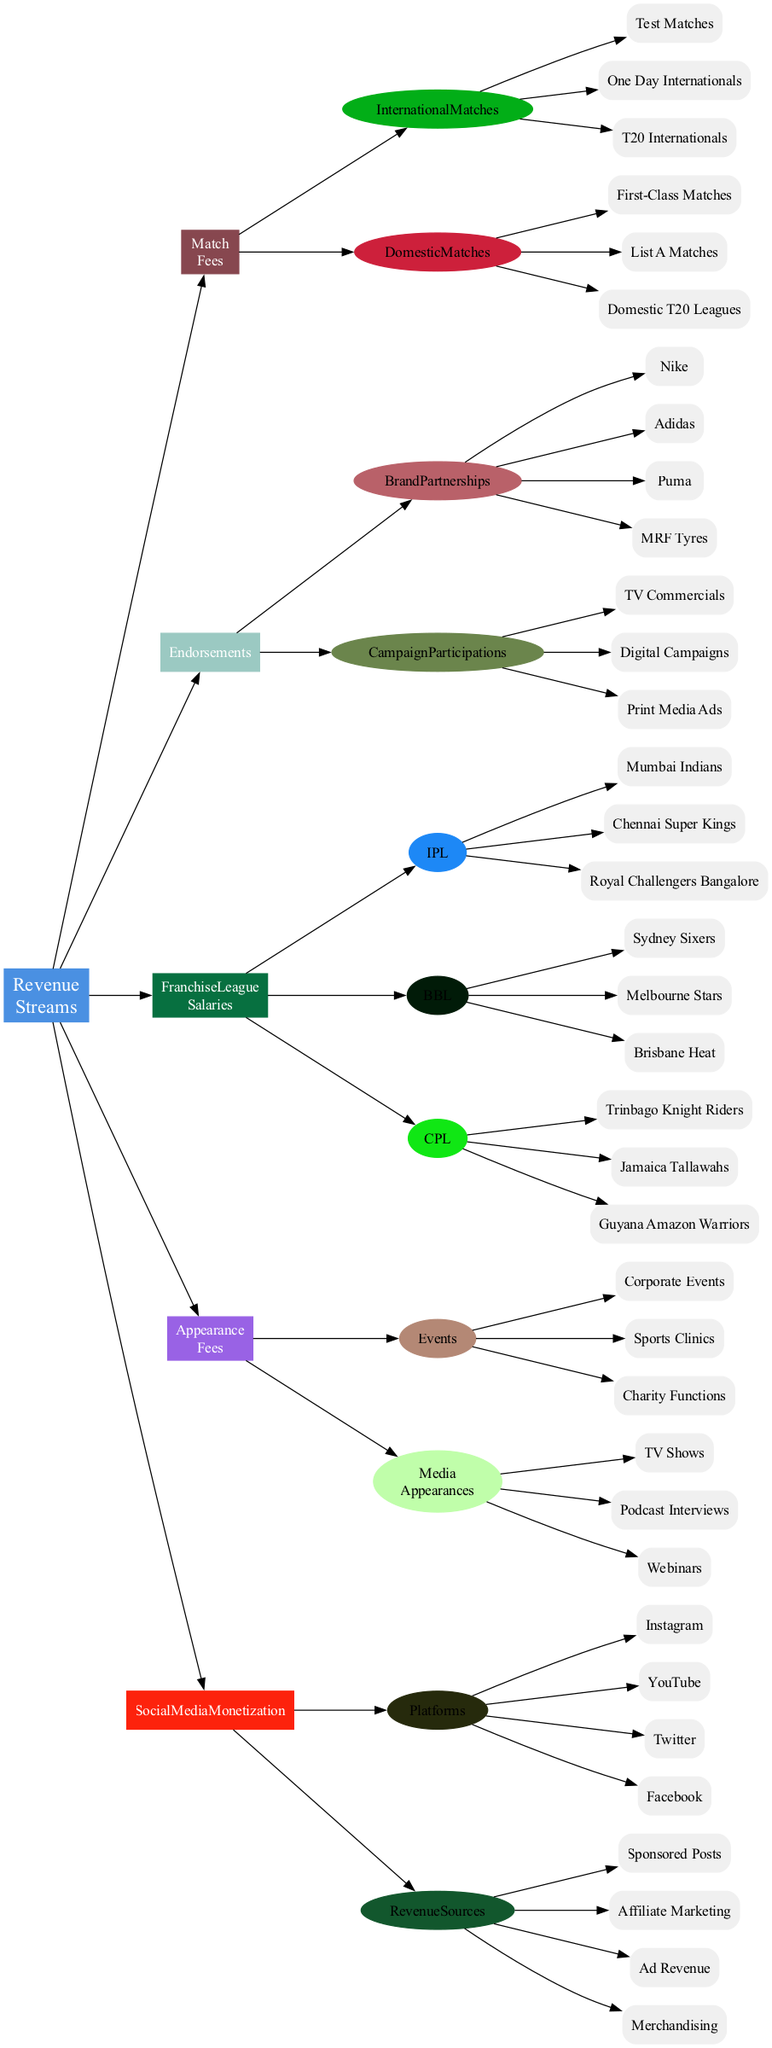What are the main categories of revenue streams for cricket players? The main categories of revenue streams are clearly listed as nodes branching directly from the central node "Revenue Streams". They include Match Fees, Endorsements, Franchise League Salaries, Appearance Fees, and Social Media Monetization.
Answer: Match Fees, Endorsements, Franchise League Salaries, Appearance Fees, Social Media Monetization How many types of international matches are included under Match Fees? By examining the sub-nodes of the "Match Fees" category, there are three types listed under "International Matches": Test Matches, One Day Internationals, and T20 Internationals.
Answer: 3 Which brands are associated with Endorsements? The "Endorsements" category has a sub-node called "Brand Partnerships" that lists brands. The brands included are Nike, Adidas, Puma, and MRF Tyres.
Answer: Nike, Adidas, Puma, MRF Tyres What are the sources of revenue listed under Social Media Monetization? The "Social Media Monetization" category contains a sub-node "Revenue Sources" with four items listed: Sponsored Posts, Affiliate Marketing, Ad Revenue, and Merchandising.
Answer: Sponsored Posts, Affiliate Marketing, Ad Revenue, Merchandising Which franchise league has the most teams in the diagram? Examining the "Franchise League Salaries" category, the IPL contains three teams: Mumbai Indians, Chennai Super Kings, and Royal Challengers Bangalore. The other leagues (BBL and CPL) also contain three, making them equally represented. Thus, they all have the same number of teams.
Answer: Equal representation How many different types of appearance fees are detailed under Appearance Fees? Looking at the "Appearance Fees" category, there are two subcategories presented: "Events" and "Media Appearances". Each has multiple listed types, indicating there are two distinct kinds of revenue defined.
Answer: 2 What monetization platforms are specified under Social Media Monetization? The "Social Media Monetization" category lists a sub-node called "Platforms". The platforms identified are Instagram, YouTube, Twitter, and Facebook, indicating these are the primary social media channels considered.
Answer: Instagram, YouTube, Twitter, Facebook How does Franchise League Salaries categorize leagues? In the "Franchise League Salaries" section, leagues are listed under three separate subcategories: IPL, BBL, and CPL, indicating a clear organization of franchise leagues for cricket players reflecting distinct leagues.
Answer: IPL, BBL, CPL What type of events are included under the Appearance Fees category? The "Appearance Fees" category specifically identifies "Events" as a subcategory, which includes Corporate Events, Sports Clinics, and Charity Functions, showing a diversity in types of events where players can earn.
Answer: Corporate Events, Sports Clinics, Charity Functions 